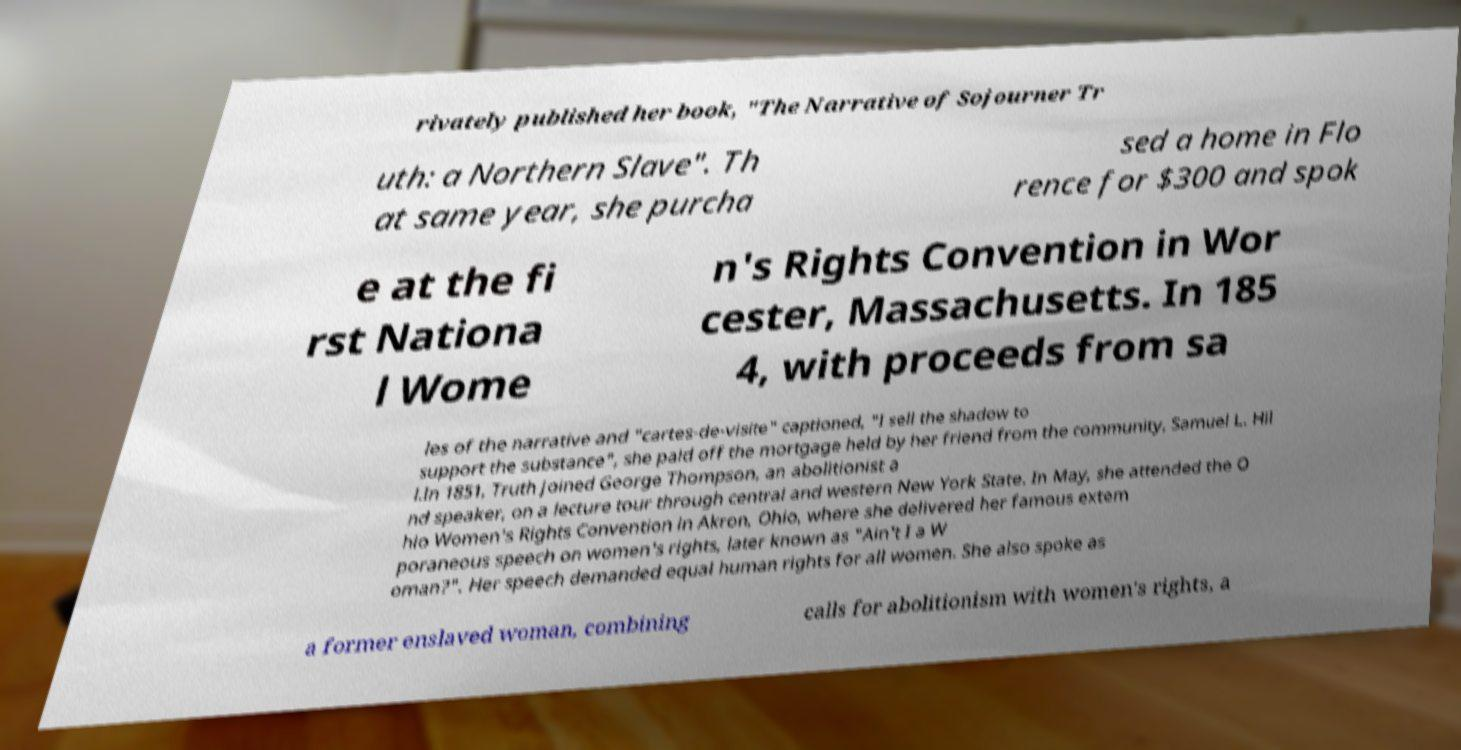Can you read and provide the text displayed in the image?This photo seems to have some interesting text. Can you extract and type it out for me? rivately published her book, "The Narrative of Sojourner Tr uth: a Northern Slave". Th at same year, she purcha sed a home in Flo rence for $300 and spok e at the fi rst Nationa l Wome n's Rights Convention in Wor cester, Massachusetts. In 185 4, with proceeds from sa les of the narrative and "cartes-de-visite" captioned, "I sell the shadow to support the substance", she paid off the mortgage held by her friend from the community, Samuel L. Hil l.In 1851, Truth joined George Thompson, an abolitionist a nd speaker, on a lecture tour through central and western New York State. In May, she attended the O hio Women's Rights Convention in Akron, Ohio, where she delivered her famous extem poraneous speech on women's rights, later known as "Ain't I a W oman?". Her speech demanded equal human rights for all women. She also spoke as a former enslaved woman, combining calls for abolitionism with women's rights, a 